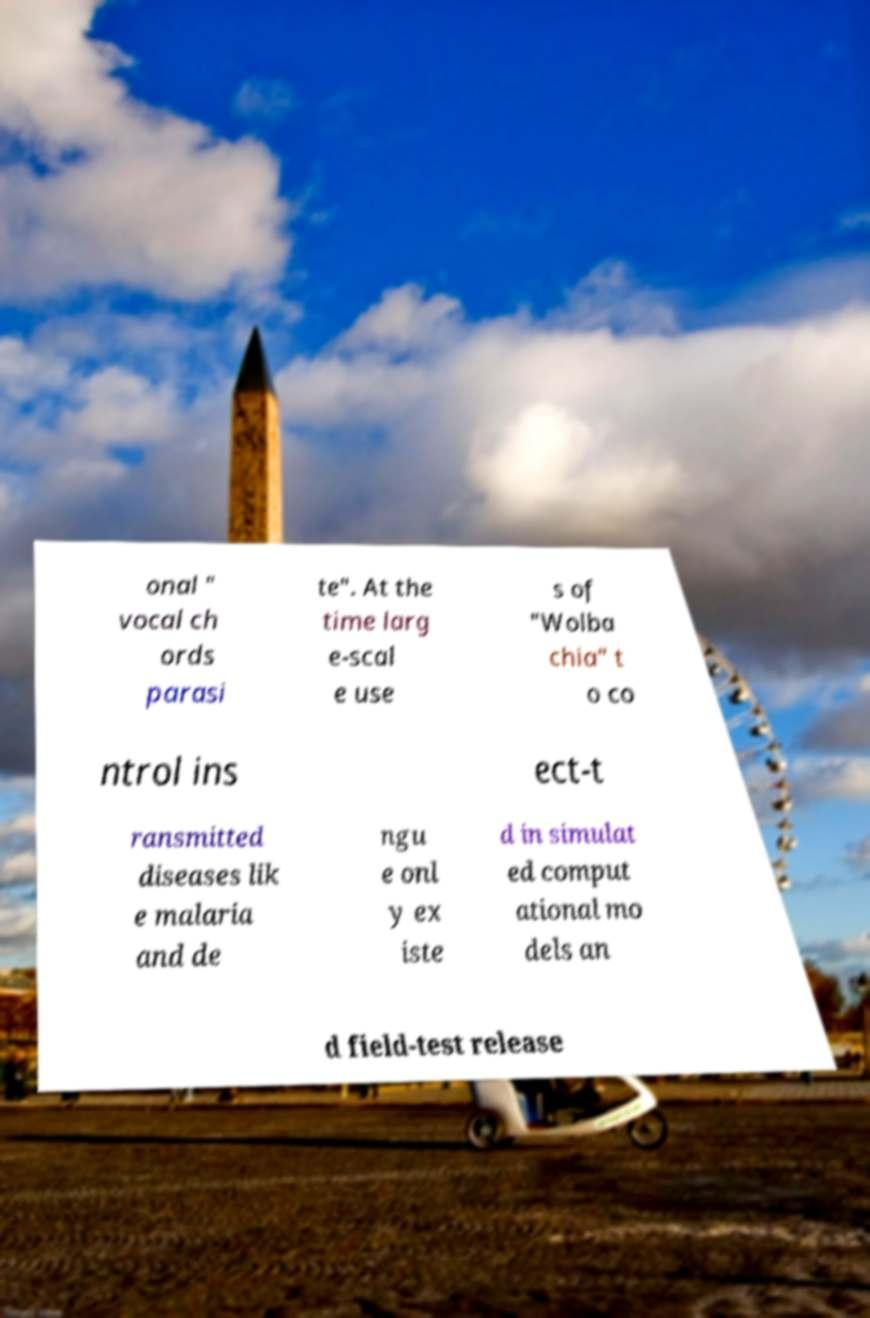Please read and relay the text visible in this image. What does it say? onal " vocal ch ords parasi te". At the time larg e-scal e use s of "Wolba chia" t o co ntrol ins ect-t ransmitted diseases lik e malaria and de ngu e onl y ex iste d in simulat ed comput ational mo dels an d field-test release 